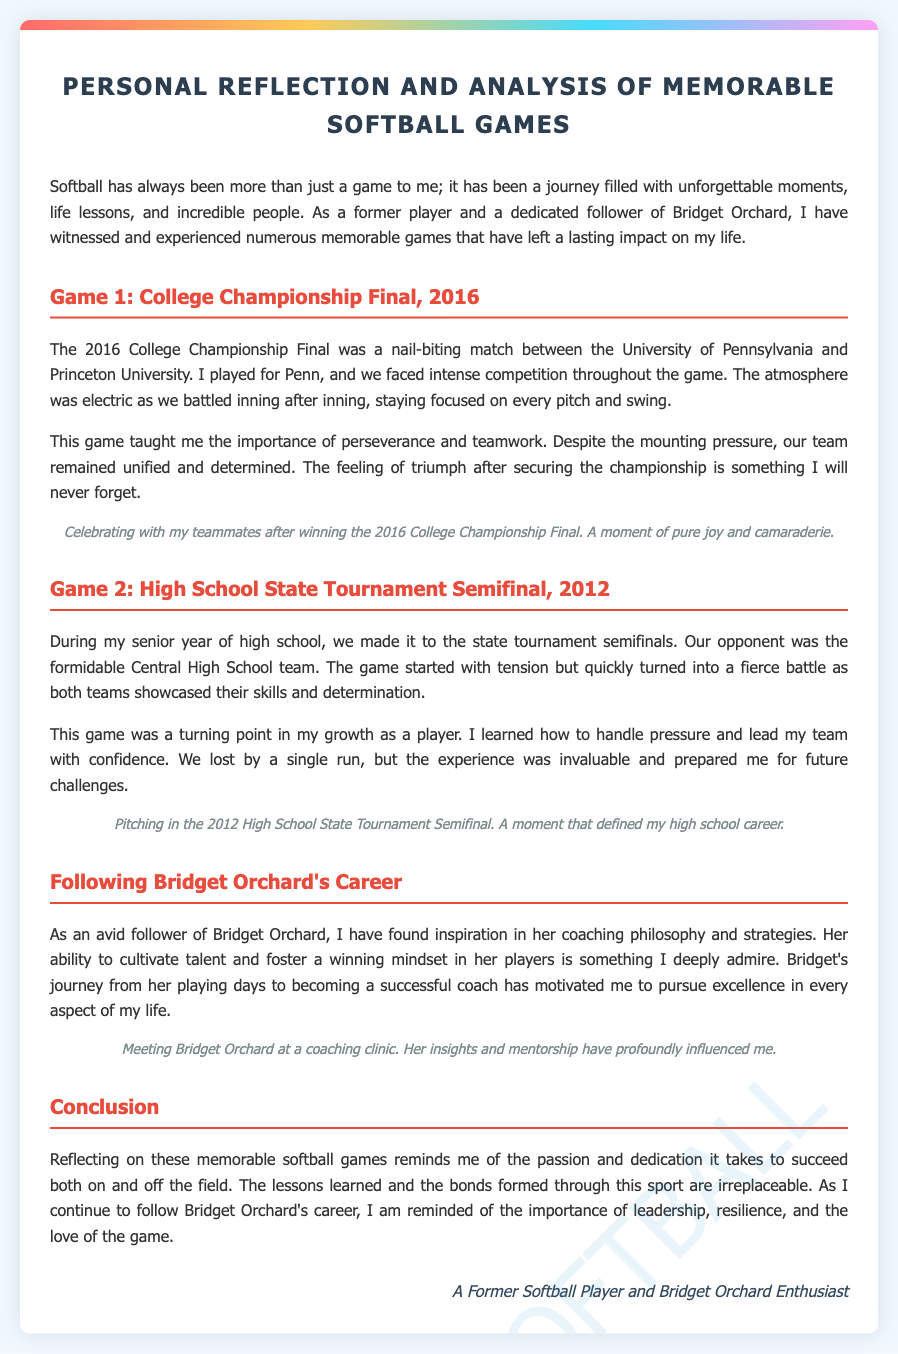What year did the College Championship Final take place? The College Championship Final is specified as taking place in 2016.
Answer: 2016 What team did the author play for in the College Championship Final? The author played for the University of Pennsylvania in the College Championship Final.
Answer: University of Pennsylvania Which team was the author's opponent in the High School State Tournament Semifinal? The opponent in the High School State Tournament Semifinal was Central High School.
Answer: Central High School What was the outcome of the High School State Tournament Semifinal? The game ended with the author’s team losing by a single run.
Answer: Lost by a single run What lesson did the author learn from the College Championship Final? The author learned the importance of perseverance and teamwork from the game.
Answer: Perseverance and teamwork How did Bridget Orchard influence the author? Bridget Orchard influenced the author through her coaching philosophy and strategies.
Answer: Coaching philosophy and strategies What type of moment is described in the photo caption for the College Championship Final? The photo caption describes a moment of pure joy and camaraderie after winning the game.
Answer: Joy and camaraderie What does the author reflect on in the conclusion? The author reflects on the passion and dedication it takes to succeed both on and off the field.
Answer: Passion and dedication What does the document primarily focus on? The document primarily focuses on personal reflections and analyses of memorable softball games.
Answer: Personal reflections and analyses 